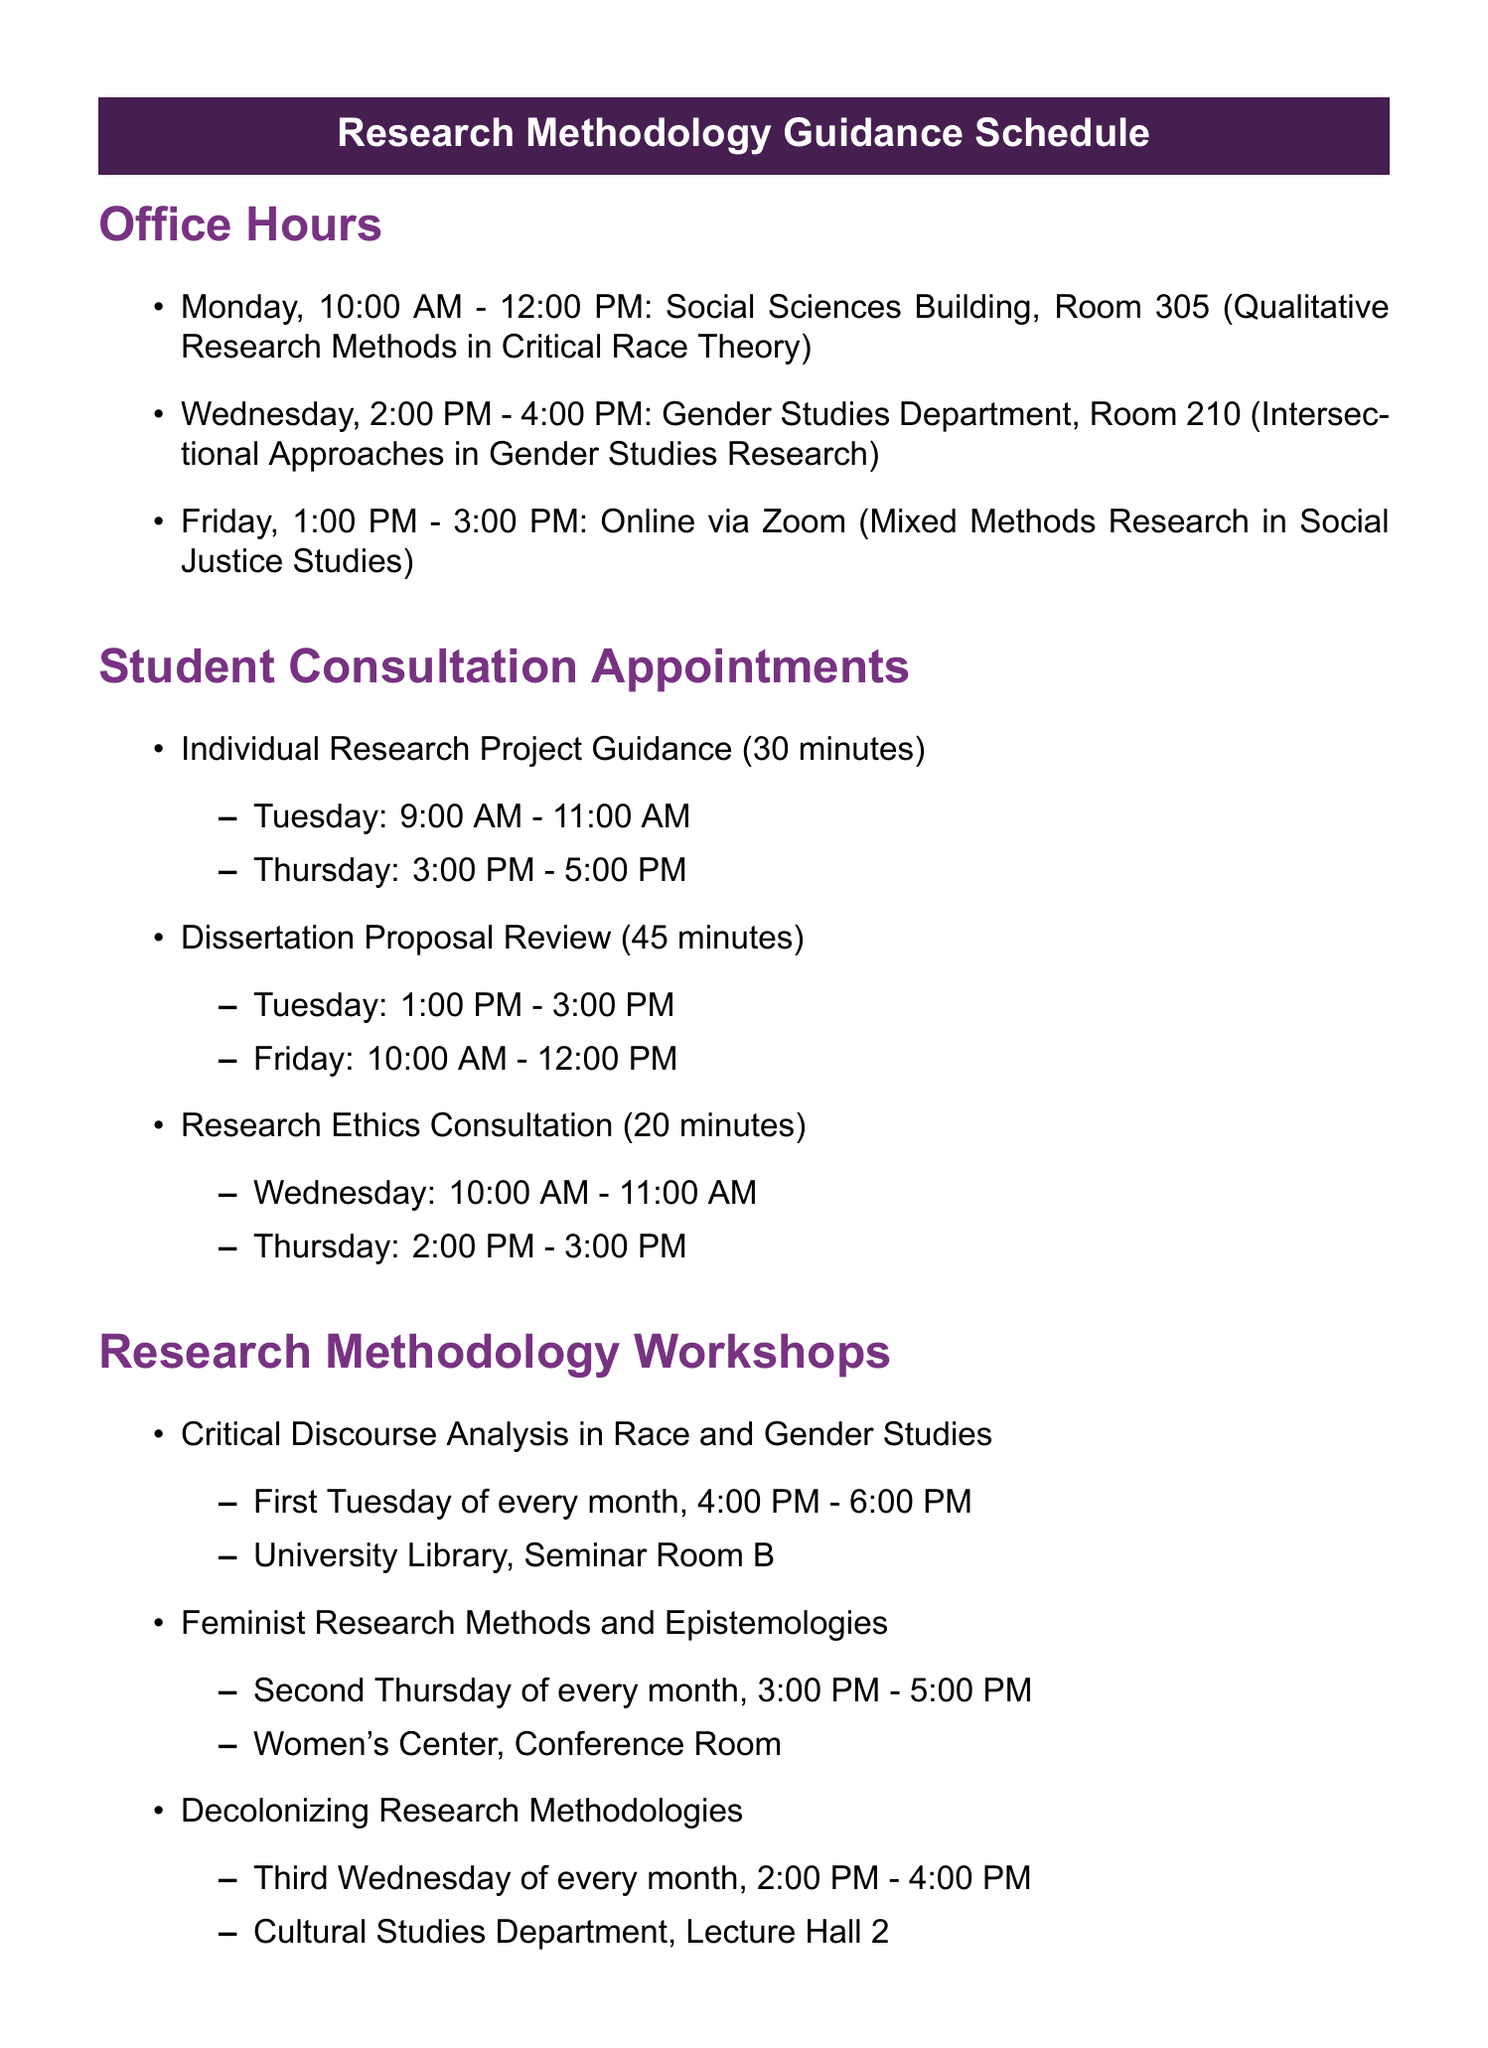What day is the workshop on Critical Discourse Analysis? The workshop on Critical Discourse Analysis is scheduled for the first Tuesday of every month.
Answer: First Tuesday What is the location for the Feminist Research Methods workshop? The location for the Feminist Research Methods workshop is Women's Center, Conference Room.
Answer: Women's Center, Conference Room How long is the Individual Research Project Guidance appointment? The duration of the Individual Research Project Guidance appointment is 30 minutes.
Answer: 30 minutes When can students schedule an appointment for Research Ethics Consultation? Students can schedule a Research Ethics Consultation on Wednesday or Thursday at specified times.
Answer: Wednesday or Thursday What is the focus of the office hours held on Friday? The focus of the office hours held on Friday is Mixed Methods Research in Social Justice Studies.
Answer: Mixed Methods Research in Social Justice Studies How often are Journal Selection Consultations held? Journal Selection Consultations are held bi-weekly.
Answer: Bi-weekly What type of guidance is offered in the monthly publication sessions? The monthly publication sessions offer manuscript review guidance.
Answer: Manuscript Review Which research resource is updated monthly? The resource that is updated monthly is the Critical Race Theory Research Guide.
Answer: Critical Race Theory Research Guide What coordination system is used for booking Individual Research Project Guidance? The booking system for Individual Research Project Guidance is Calendly.
Answer: Calendly 